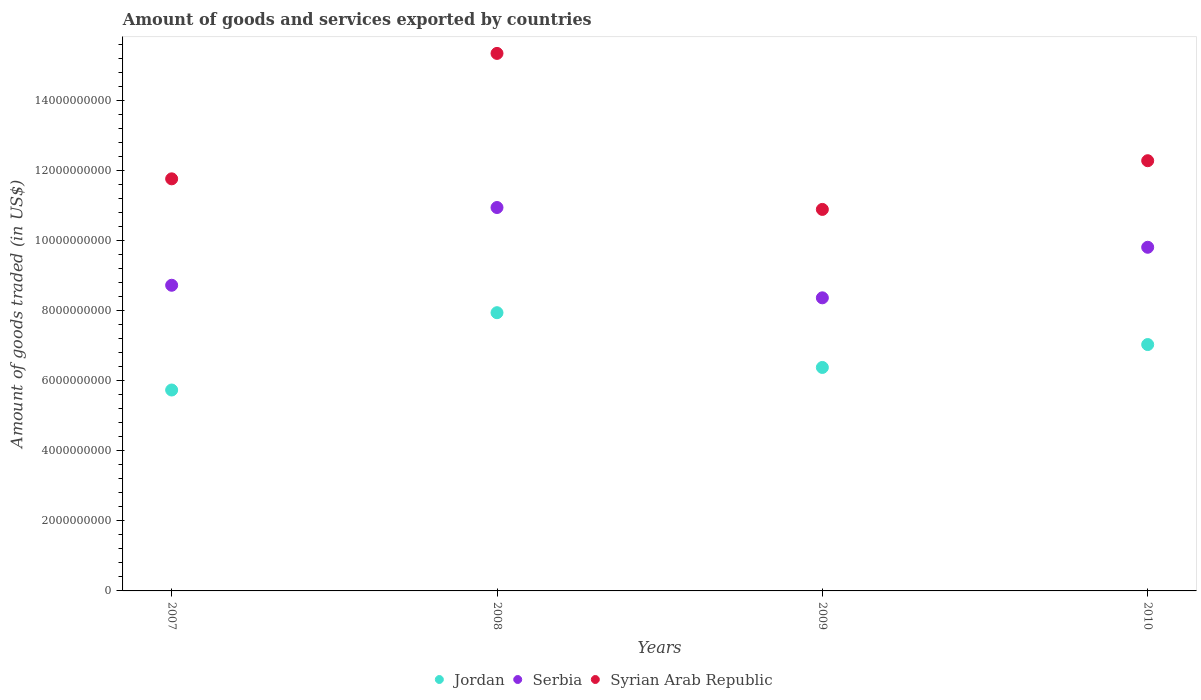Is the number of dotlines equal to the number of legend labels?
Give a very brief answer. Yes. What is the total amount of goods and services exported in Serbia in 2008?
Your response must be concise. 1.09e+1. Across all years, what is the maximum total amount of goods and services exported in Syrian Arab Republic?
Your answer should be compact. 1.53e+1. Across all years, what is the minimum total amount of goods and services exported in Syrian Arab Republic?
Provide a succinct answer. 1.09e+1. What is the total total amount of goods and services exported in Jordan in the graph?
Your answer should be very brief. 2.71e+1. What is the difference between the total amount of goods and services exported in Syrian Arab Republic in 2007 and that in 2008?
Provide a short and direct response. -3.58e+09. What is the difference between the total amount of goods and services exported in Jordan in 2008 and the total amount of goods and services exported in Syrian Arab Republic in 2007?
Give a very brief answer. -3.82e+09. What is the average total amount of goods and services exported in Jordan per year?
Ensure brevity in your answer.  6.77e+09. In the year 2008, what is the difference between the total amount of goods and services exported in Syrian Arab Republic and total amount of goods and services exported in Jordan?
Provide a short and direct response. 7.40e+09. In how many years, is the total amount of goods and services exported in Syrian Arab Republic greater than 7200000000 US$?
Your response must be concise. 4. What is the ratio of the total amount of goods and services exported in Serbia in 2007 to that in 2009?
Provide a short and direct response. 1.04. Is the total amount of goods and services exported in Serbia in 2008 less than that in 2009?
Provide a short and direct response. No. What is the difference between the highest and the second highest total amount of goods and services exported in Serbia?
Make the answer very short. 1.13e+09. What is the difference between the highest and the lowest total amount of goods and services exported in Jordan?
Give a very brief answer. 2.21e+09. Is the sum of the total amount of goods and services exported in Syrian Arab Republic in 2008 and 2010 greater than the maximum total amount of goods and services exported in Jordan across all years?
Keep it short and to the point. Yes. Does the total amount of goods and services exported in Syrian Arab Republic monotonically increase over the years?
Your answer should be very brief. No. How many years are there in the graph?
Your response must be concise. 4. What is the difference between two consecutive major ticks on the Y-axis?
Keep it short and to the point. 2.00e+09. Does the graph contain any zero values?
Offer a very short reply. No. Where does the legend appear in the graph?
Your answer should be very brief. Bottom center. How are the legend labels stacked?
Your response must be concise. Horizontal. What is the title of the graph?
Give a very brief answer. Amount of goods and services exported by countries. What is the label or title of the Y-axis?
Provide a short and direct response. Amount of goods traded (in US$). What is the Amount of goods traded (in US$) in Jordan in 2007?
Your answer should be very brief. 5.73e+09. What is the Amount of goods traded (in US$) of Serbia in 2007?
Your response must be concise. 8.72e+09. What is the Amount of goods traded (in US$) in Syrian Arab Republic in 2007?
Offer a very short reply. 1.18e+1. What is the Amount of goods traded (in US$) of Jordan in 2008?
Give a very brief answer. 7.94e+09. What is the Amount of goods traded (in US$) in Serbia in 2008?
Provide a succinct answer. 1.09e+1. What is the Amount of goods traded (in US$) of Syrian Arab Republic in 2008?
Offer a very short reply. 1.53e+1. What is the Amount of goods traded (in US$) in Jordan in 2009?
Keep it short and to the point. 6.38e+09. What is the Amount of goods traded (in US$) of Serbia in 2009?
Keep it short and to the point. 8.36e+09. What is the Amount of goods traded (in US$) of Syrian Arab Republic in 2009?
Offer a very short reply. 1.09e+1. What is the Amount of goods traded (in US$) of Jordan in 2010?
Ensure brevity in your answer.  7.03e+09. What is the Amount of goods traded (in US$) in Serbia in 2010?
Provide a succinct answer. 9.80e+09. What is the Amount of goods traded (in US$) of Syrian Arab Republic in 2010?
Offer a terse response. 1.23e+1. Across all years, what is the maximum Amount of goods traded (in US$) of Jordan?
Offer a very short reply. 7.94e+09. Across all years, what is the maximum Amount of goods traded (in US$) of Serbia?
Provide a short and direct response. 1.09e+1. Across all years, what is the maximum Amount of goods traded (in US$) in Syrian Arab Republic?
Provide a short and direct response. 1.53e+1. Across all years, what is the minimum Amount of goods traded (in US$) of Jordan?
Offer a terse response. 5.73e+09. Across all years, what is the minimum Amount of goods traded (in US$) in Serbia?
Offer a terse response. 8.36e+09. Across all years, what is the minimum Amount of goods traded (in US$) in Syrian Arab Republic?
Make the answer very short. 1.09e+1. What is the total Amount of goods traded (in US$) of Jordan in the graph?
Ensure brevity in your answer.  2.71e+1. What is the total Amount of goods traded (in US$) in Serbia in the graph?
Ensure brevity in your answer.  3.78e+1. What is the total Amount of goods traded (in US$) in Syrian Arab Republic in the graph?
Offer a terse response. 5.02e+1. What is the difference between the Amount of goods traded (in US$) in Jordan in 2007 and that in 2008?
Your response must be concise. -2.21e+09. What is the difference between the Amount of goods traded (in US$) of Serbia in 2007 and that in 2008?
Your response must be concise. -2.22e+09. What is the difference between the Amount of goods traded (in US$) in Syrian Arab Republic in 2007 and that in 2008?
Your answer should be very brief. -3.58e+09. What is the difference between the Amount of goods traded (in US$) in Jordan in 2007 and that in 2009?
Offer a very short reply. -6.44e+08. What is the difference between the Amount of goods traded (in US$) in Serbia in 2007 and that in 2009?
Your answer should be compact. 3.58e+08. What is the difference between the Amount of goods traded (in US$) in Syrian Arab Republic in 2007 and that in 2009?
Your response must be concise. 8.72e+08. What is the difference between the Amount of goods traded (in US$) of Jordan in 2007 and that in 2010?
Provide a succinct answer. -1.30e+09. What is the difference between the Amount of goods traded (in US$) of Serbia in 2007 and that in 2010?
Give a very brief answer. -1.08e+09. What is the difference between the Amount of goods traded (in US$) of Syrian Arab Republic in 2007 and that in 2010?
Give a very brief answer. -5.17e+08. What is the difference between the Amount of goods traded (in US$) in Jordan in 2008 and that in 2009?
Your response must be concise. 1.56e+09. What is the difference between the Amount of goods traded (in US$) in Serbia in 2008 and that in 2009?
Keep it short and to the point. 2.58e+09. What is the difference between the Amount of goods traded (in US$) in Syrian Arab Republic in 2008 and that in 2009?
Give a very brief answer. 4.45e+09. What is the difference between the Amount of goods traded (in US$) in Jordan in 2008 and that in 2010?
Your answer should be compact. 9.09e+08. What is the difference between the Amount of goods traded (in US$) in Serbia in 2008 and that in 2010?
Your answer should be compact. 1.13e+09. What is the difference between the Amount of goods traded (in US$) in Syrian Arab Republic in 2008 and that in 2010?
Your answer should be compact. 3.06e+09. What is the difference between the Amount of goods traded (in US$) in Jordan in 2009 and that in 2010?
Offer a very short reply. -6.53e+08. What is the difference between the Amount of goods traded (in US$) of Serbia in 2009 and that in 2010?
Give a very brief answer. -1.44e+09. What is the difference between the Amount of goods traded (in US$) of Syrian Arab Republic in 2009 and that in 2010?
Keep it short and to the point. -1.39e+09. What is the difference between the Amount of goods traded (in US$) in Jordan in 2007 and the Amount of goods traded (in US$) in Serbia in 2008?
Offer a very short reply. -5.21e+09. What is the difference between the Amount of goods traded (in US$) in Jordan in 2007 and the Amount of goods traded (in US$) in Syrian Arab Republic in 2008?
Offer a very short reply. -9.60e+09. What is the difference between the Amount of goods traded (in US$) in Serbia in 2007 and the Amount of goods traded (in US$) in Syrian Arab Republic in 2008?
Your answer should be very brief. -6.61e+09. What is the difference between the Amount of goods traded (in US$) of Jordan in 2007 and the Amount of goods traded (in US$) of Serbia in 2009?
Offer a terse response. -2.63e+09. What is the difference between the Amount of goods traded (in US$) in Jordan in 2007 and the Amount of goods traded (in US$) in Syrian Arab Republic in 2009?
Ensure brevity in your answer.  -5.15e+09. What is the difference between the Amount of goods traded (in US$) in Serbia in 2007 and the Amount of goods traded (in US$) in Syrian Arab Republic in 2009?
Your answer should be compact. -2.16e+09. What is the difference between the Amount of goods traded (in US$) of Jordan in 2007 and the Amount of goods traded (in US$) of Serbia in 2010?
Keep it short and to the point. -4.07e+09. What is the difference between the Amount of goods traded (in US$) in Jordan in 2007 and the Amount of goods traded (in US$) in Syrian Arab Republic in 2010?
Ensure brevity in your answer.  -6.54e+09. What is the difference between the Amount of goods traded (in US$) in Serbia in 2007 and the Amount of goods traded (in US$) in Syrian Arab Republic in 2010?
Your answer should be very brief. -3.55e+09. What is the difference between the Amount of goods traded (in US$) in Jordan in 2008 and the Amount of goods traded (in US$) in Serbia in 2009?
Make the answer very short. -4.24e+08. What is the difference between the Amount of goods traded (in US$) in Jordan in 2008 and the Amount of goods traded (in US$) in Syrian Arab Republic in 2009?
Offer a very short reply. -2.95e+09. What is the difference between the Amount of goods traded (in US$) of Serbia in 2008 and the Amount of goods traded (in US$) of Syrian Arab Republic in 2009?
Your response must be concise. 5.41e+07. What is the difference between the Amount of goods traded (in US$) of Jordan in 2008 and the Amount of goods traded (in US$) of Serbia in 2010?
Your response must be concise. -1.87e+09. What is the difference between the Amount of goods traded (in US$) in Jordan in 2008 and the Amount of goods traded (in US$) in Syrian Arab Republic in 2010?
Make the answer very short. -4.34e+09. What is the difference between the Amount of goods traded (in US$) of Serbia in 2008 and the Amount of goods traded (in US$) of Syrian Arab Republic in 2010?
Give a very brief answer. -1.34e+09. What is the difference between the Amount of goods traded (in US$) in Jordan in 2009 and the Amount of goods traded (in US$) in Serbia in 2010?
Your answer should be compact. -3.43e+09. What is the difference between the Amount of goods traded (in US$) in Jordan in 2009 and the Amount of goods traded (in US$) in Syrian Arab Republic in 2010?
Your answer should be very brief. -5.90e+09. What is the difference between the Amount of goods traded (in US$) in Serbia in 2009 and the Amount of goods traded (in US$) in Syrian Arab Republic in 2010?
Provide a short and direct response. -3.91e+09. What is the average Amount of goods traded (in US$) of Jordan per year?
Offer a terse response. 6.77e+09. What is the average Amount of goods traded (in US$) in Serbia per year?
Make the answer very short. 9.46e+09. What is the average Amount of goods traded (in US$) of Syrian Arab Republic per year?
Keep it short and to the point. 1.26e+1. In the year 2007, what is the difference between the Amount of goods traded (in US$) in Jordan and Amount of goods traded (in US$) in Serbia?
Provide a short and direct response. -2.99e+09. In the year 2007, what is the difference between the Amount of goods traded (in US$) of Jordan and Amount of goods traded (in US$) of Syrian Arab Republic?
Ensure brevity in your answer.  -6.02e+09. In the year 2007, what is the difference between the Amount of goods traded (in US$) of Serbia and Amount of goods traded (in US$) of Syrian Arab Republic?
Your answer should be very brief. -3.04e+09. In the year 2008, what is the difference between the Amount of goods traded (in US$) in Jordan and Amount of goods traded (in US$) in Serbia?
Offer a terse response. -3.00e+09. In the year 2008, what is the difference between the Amount of goods traded (in US$) of Jordan and Amount of goods traded (in US$) of Syrian Arab Republic?
Ensure brevity in your answer.  -7.40e+09. In the year 2008, what is the difference between the Amount of goods traded (in US$) in Serbia and Amount of goods traded (in US$) in Syrian Arab Republic?
Your answer should be very brief. -4.40e+09. In the year 2009, what is the difference between the Amount of goods traded (in US$) in Jordan and Amount of goods traded (in US$) in Serbia?
Your answer should be very brief. -1.99e+09. In the year 2009, what is the difference between the Amount of goods traded (in US$) in Jordan and Amount of goods traded (in US$) in Syrian Arab Republic?
Provide a succinct answer. -4.51e+09. In the year 2009, what is the difference between the Amount of goods traded (in US$) of Serbia and Amount of goods traded (in US$) of Syrian Arab Republic?
Your answer should be very brief. -2.52e+09. In the year 2010, what is the difference between the Amount of goods traded (in US$) in Jordan and Amount of goods traded (in US$) in Serbia?
Keep it short and to the point. -2.78e+09. In the year 2010, what is the difference between the Amount of goods traded (in US$) of Jordan and Amount of goods traded (in US$) of Syrian Arab Republic?
Offer a very short reply. -5.24e+09. In the year 2010, what is the difference between the Amount of goods traded (in US$) in Serbia and Amount of goods traded (in US$) in Syrian Arab Republic?
Provide a succinct answer. -2.47e+09. What is the ratio of the Amount of goods traded (in US$) of Jordan in 2007 to that in 2008?
Provide a short and direct response. 0.72. What is the ratio of the Amount of goods traded (in US$) in Serbia in 2007 to that in 2008?
Make the answer very short. 0.8. What is the ratio of the Amount of goods traded (in US$) of Syrian Arab Republic in 2007 to that in 2008?
Your answer should be compact. 0.77. What is the ratio of the Amount of goods traded (in US$) in Jordan in 2007 to that in 2009?
Your response must be concise. 0.9. What is the ratio of the Amount of goods traded (in US$) in Serbia in 2007 to that in 2009?
Your answer should be compact. 1.04. What is the ratio of the Amount of goods traded (in US$) of Syrian Arab Republic in 2007 to that in 2009?
Ensure brevity in your answer.  1.08. What is the ratio of the Amount of goods traded (in US$) of Jordan in 2007 to that in 2010?
Make the answer very short. 0.82. What is the ratio of the Amount of goods traded (in US$) in Serbia in 2007 to that in 2010?
Provide a succinct answer. 0.89. What is the ratio of the Amount of goods traded (in US$) in Syrian Arab Republic in 2007 to that in 2010?
Keep it short and to the point. 0.96. What is the ratio of the Amount of goods traded (in US$) in Jordan in 2008 to that in 2009?
Provide a succinct answer. 1.25. What is the ratio of the Amount of goods traded (in US$) in Serbia in 2008 to that in 2009?
Offer a very short reply. 1.31. What is the ratio of the Amount of goods traded (in US$) of Syrian Arab Republic in 2008 to that in 2009?
Keep it short and to the point. 1.41. What is the ratio of the Amount of goods traded (in US$) of Jordan in 2008 to that in 2010?
Your answer should be compact. 1.13. What is the ratio of the Amount of goods traded (in US$) of Serbia in 2008 to that in 2010?
Provide a short and direct response. 1.12. What is the ratio of the Amount of goods traded (in US$) in Syrian Arab Republic in 2008 to that in 2010?
Provide a short and direct response. 1.25. What is the ratio of the Amount of goods traded (in US$) in Jordan in 2009 to that in 2010?
Make the answer very short. 0.91. What is the ratio of the Amount of goods traded (in US$) in Serbia in 2009 to that in 2010?
Provide a succinct answer. 0.85. What is the ratio of the Amount of goods traded (in US$) in Syrian Arab Republic in 2009 to that in 2010?
Make the answer very short. 0.89. What is the difference between the highest and the second highest Amount of goods traded (in US$) of Jordan?
Your answer should be compact. 9.09e+08. What is the difference between the highest and the second highest Amount of goods traded (in US$) of Serbia?
Your answer should be compact. 1.13e+09. What is the difference between the highest and the second highest Amount of goods traded (in US$) of Syrian Arab Republic?
Offer a very short reply. 3.06e+09. What is the difference between the highest and the lowest Amount of goods traded (in US$) of Jordan?
Provide a succinct answer. 2.21e+09. What is the difference between the highest and the lowest Amount of goods traded (in US$) in Serbia?
Your answer should be very brief. 2.58e+09. What is the difference between the highest and the lowest Amount of goods traded (in US$) in Syrian Arab Republic?
Ensure brevity in your answer.  4.45e+09. 